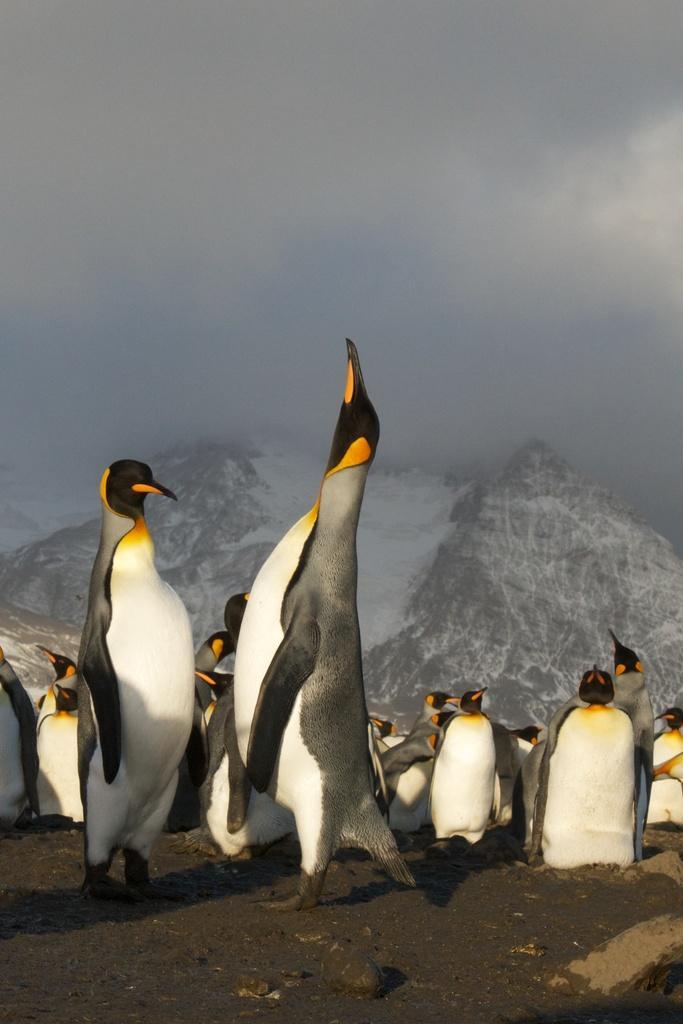In one or two sentences, can you explain what this image depicts? In this picture I can see penguins, there are snowy mountains, and in the background there is the sky. 